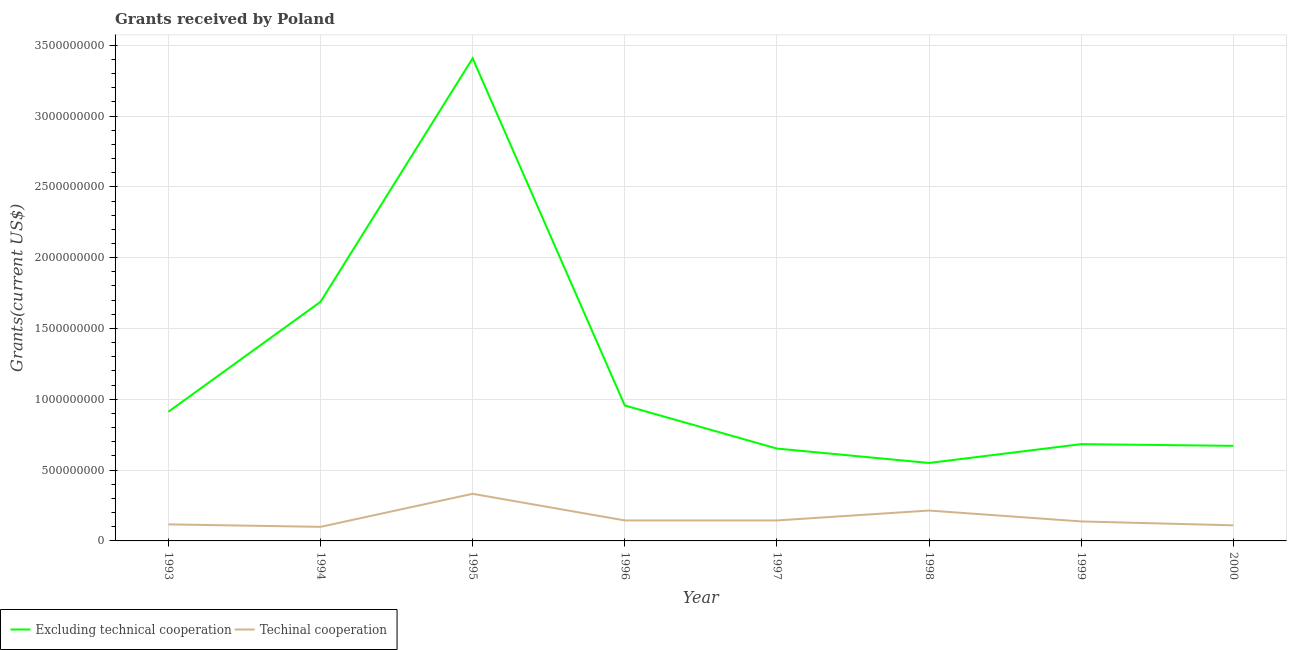What is the amount of grants received(excluding technical cooperation) in 1996?
Make the answer very short. 9.56e+08. Across all years, what is the maximum amount of grants received(including technical cooperation)?
Offer a terse response. 3.33e+08. Across all years, what is the minimum amount of grants received(including technical cooperation)?
Your answer should be compact. 9.94e+07. In which year was the amount of grants received(including technical cooperation) maximum?
Keep it short and to the point. 1995. What is the total amount of grants received(including technical cooperation) in the graph?
Your answer should be very brief. 1.30e+09. What is the difference between the amount of grants received(excluding technical cooperation) in 1997 and that in 1998?
Provide a short and direct response. 1.02e+08. What is the difference between the amount of grants received(including technical cooperation) in 1994 and the amount of grants received(excluding technical cooperation) in 1993?
Offer a very short reply. -8.13e+08. What is the average amount of grants received(including technical cooperation) per year?
Your answer should be very brief. 1.63e+08. In the year 1999, what is the difference between the amount of grants received(including technical cooperation) and amount of grants received(excluding technical cooperation)?
Ensure brevity in your answer.  -5.46e+08. In how many years, is the amount of grants received(excluding technical cooperation) greater than 1900000000 US$?
Your response must be concise. 1. What is the ratio of the amount of grants received(including technical cooperation) in 1999 to that in 2000?
Your response must be concise. 1.25. What is the difference between the highest and the second highest amount of grants received(excluding technical cooperation)?
Your response must be concise. 1.72e+09. What is the difference between the highest and the lowest amount of grants received(excluding technical cooperation)?
Offer a very short reply. 2.86e+09. Is the sum of the amount of grants received(excluding technical cooperation) in 1995 and 1997 greater than the maximum amount of grants received(including technical cooperation) across all years?
Provide a short and direct response. Yes. Is the amount of grants received(including technical cooperation) strictly less than the amount of grants received(excluding technical cooperation) over the years?
Give a very brief answer. Yes. How many years are there in the graph?
Keep it short and to the point. 8. What is the difference between two consecutive major ticks on the Y-axis?
Make the answer very short. 5.00e+08. Are the values on the major ticks of Y-axis written in scientific E-notation?
Give a very brief answer. No. Does the graph contain any zero values?
Make the answer very short. No. Does the graph contain grids?
Make the answer very short. Yes. Where does the legend appear in the graph?
Provide a short and direct response. Bottom left. How are the legend labels stacked?
Provide a succinct answer. Horizontal. What is the title of the graph?
Your answer should be very brief. Grants received by Poland. What is the label or title of the X-axis?
Your answer should be compact. Year. What is the label or title of the Y-axis?
Your answer should be very brief. Grants(current US$). What is the Grants(current US$) in Excluding technical cooperation in 1993?
Offer a very short reply. 9.12e+08. What is the Grants(current US$) of Techinal cooperation in 1993?
Your response must be concise. 1.17e+08. What is the Grants(current US$) of Excluding technical cooperation in 1994?
Your response must be concise. 1.69e+09. What is the Grants(current US$) of Techinal cooperation in 1994?
Your answer should be compact. 9.94e+07. What is the Grants(current US$) of Excluding technical cooperation in 1995?
Offer a very short reply. 3.41e+09. What is the Grants(current US$) of Techinal cooperation in 1995?
Make the answer very short. 3.33e+08. What is the Grants(current US$) of Excluding technical cooperation in 1996?
Give a very brief answer. 9.56e+08. What is the Grants(current US$) of Techinal cooperation in 1996?
Your answer should be very brief. 1.45e+08. What is the Grants(current US$) in Excluding technical cooperation in 1997?
Your answer should be compact. 6.52e+08. What is the Grants(current US$) in Techinal cooperation in 1997?
Provide a succinct answer. 1.45e+08. What is the Grants(current US$) in Excluding technical cooperation in 1998?
Provide a succinct answer. 5.50e+08. What is the Grants(current US$) in Techinal cooperation in 1998?
Ensure brevity in your answer.  2.15e+08. What is the Grants(current US$) of Excluding technical cooperation in 1999?
Your answer should be compact. 6.83e+08. What is the Grants(current US$) in Techinal cooperation in 1999?
Keep it short and to the point. 1.38e+08. What is the Grants(current US$) of Excluding technical cooperation in 2000?
Keep it short and to the point. 6.71e+08. What is the Grants(current US$) of Techinal cooperation in 2000?
Provide a short and direct response. 1.10e+08. Across all years, what is the maximum Grants(current US$) in Excluding technical cooperation?
Ensure brevity in your answer.  3.41e+09. Across all years, what is the maximum Grants(current US$) in Techinal cooperation?
Make the answer very short. 3.33e+08. Across all years, what is the minimum Grants(current US$) in Excluding technical cooperation?
Keep it short and to the point. 5.50e+08. Across all years, what is the minimum Grants(current US$) in Techinal cooperation?
Your response must be concise. 9.94e+07. What is the total Grants(current US$) in Excluding technical cooperation in the graph?
Provide a short and direct response. 9.52e+09. What is the total Grants(current US$) of Techinal cooperation in the graph?
Your answer should be compact. 1.30e+09. What is the difference between the Grants(current US$) of Excluding technical cooperation in 1993 and that in 1994?
Give a very brief answer. -7.76e+08. What is the difference between the Grants(current US$) of Techinal cooperation in 1993 and that in 1994?
Make the answer very short. 1.75e+07. What is the difference between the Grants(current US$) of Excluding technical cooperation in 1993 and that in 1995?
Offer a very short reply. -2.50e+09. What is the difference between the Grants(current US$) in Techinal cooperation in 1993 and that in 1995?
Offer a terse response. -2.16e+08. What is the difference between the Grants(current US$) of Excluding technical cooperation in 1993 and that in 1996?
Your answer should be compact. -4.42e+07. What is the difference between the Grants(current US$) in Techinal cooperation in 1993 and that in 1996?
Ensure brevity in your answer.  -2.78e+07. What is the difference between the Grants(current US$) in Excluding technical cooperation in 1993 and that in 1997?
Your response must be concise. 2.60e+08. What is the difference between the Grants(current US$) in Techinal cooperation in 1993 and that in 1997?
Give a very brief answer. -2.78e+07. What is the difference between the Grants(current US$) in Excluding technical cooperation in 1993 and that in 1998?
Your response must be concise. 3.62e+08. What is the difference between the Grants(current US$) in Techinal cooperation in 1993 and that in 1998?
Offer a very short reply. -9.77e+07. What is the difference between the Grants(current US$) in Excluding technical cooperation in 1993 and that in 1999?
Your answer should be compact. 2.29e+08. What is the difference between the Grants(current US$) in Techinal cooperation in 1993 and that in 1999?
Keep it short and to the point. -2.08e+07. What is the difference between the Grants(current US$) of Excluding technical cooperation in 1993 and that in 2000?
Your response must be concise. 2.41e+08. What is the difference between the Grants(current US$) in Techinal cooperation in 1993 and that in 2000?
Make the answer very short. 6.63e+06. What is the difference between the Grants(current US$) of Excluding technical cooperation in 1994 and that in 1995?
Your answer should be very brief. -1.72e+09. What is the difference between the Grants(current US$) of Techinal cooperation in 1994 and that in 1995?
Ensure brevity in your answer.  -2.33e+08. What is the difference between the Grants(current US$) in Excluding technical cooperation in 1994 and that in 1996?
Keep it short and to the point. 7.32e+08. What is the difference between the Grants(current US$) in Techinal cooperation in 1994 and that in 1996?
Keep it short and to the point. -4.53e+07. What is the difference between the Grants(current US$) of Excluding technical cooperation in 1994 and that in 1997?
Provide a short and direct response. 1.04e+09. What is the difference between the Grants(current US$) in Techinal cooperation in 1994 and that in 1997?
Your answer should be compact. -4.53e+07. What is the difference between the Grants(current US$) in Excluding technical cooperation in 1994 and that in 1998?
Offer a very short reply. 1.14e+09. What is the difference between the Grants(current US$) in Techinal cooperation in 1994 and that in 1998?
Your answer should be compact. -1.15e+08. What is the difference between the Grants(current US$) in Excluding technical cooperation in 1994 and that in 1999?
Provide a succinct answer. 1.00e+09. What is the difference between the Grants(current US$) of Techinal cooperation in 1994 and that in 1999?
Ensure brevity in your answer.  -3.82e+07. What is the difference between the Grants(current US$) of Excluding technical cooperation in 1994 and that in 2000?
Provide a short and direct response. 1.02e+09. What is the difference between the Grants(current US$) of Techinal cooperation in 1994 and that in 2000?
Give a very brief answer. -1.08e+07. What is the difference between the Grants(current US$) of Excluding technical cooperation in 1995 and that in 1996?
Give a very brief answer. 2.45e+09. What is the difference between the Grants(current US$) in Techinal cooperation in 1995 and that in 1996?
Offer a very short reply. 1.88e+08. What is the difference between the Grants(current US$) in Excluding technical cooperation in 1995 and that in 1997?
Your answer should be very brief. 2.76e+09. What is the difference between the Grants(current US$) of Techinal cooperation in 1995 and that in 1997?
Provide a short and direct response. 1.88e+08. What is the difference between the Grants(current US$) of Excluding technical cooperation in 1995 and that in 1998?
Provide a short and direct response. 2.86e+09. What is the difference between the Grants(current US$) in Techinal cooperation in 1995 and that in 1998?
Your answer should be compact. 1.18e+08. What is the difference between the Grants(current US$) in Excluding technical cooperation in 1995 and that in 1999?
Give a very brief answer. 2.72e+09. What is the difference between the Grants(current US$) in Techinal cooperation in 1995 and that in 1999?
Make the answer very short. 1.95e+08. What is the difference between the Grants(current US$) in Excluding technical cooperation in 1995 and that in 2000?
Provide a succinct answer. 2.74e+09. What is the difference between the Grants(current US$) in Techinal cooperation in 1995 and that in 2000?
Your answer should be very brief. 2.23e+08. What is the difference between the Grants(current US$) of Excluding technical cooperation in 1996 and that in 1997?
Give a very brief answer. 3.04e+08. What is the difference between the Grants(current US$) in Excluding technical cooperation in 1996 and that in 1998?
Offer a very short reply. 4.06e+08. What is the difference between the Grants(current US$) in Techinal cooperation in 1996 and that in 1998?
Your response must be concise. -6.99e+07. What is the difference between the Grants(current US$) in Excluding technical cooperation in 1996 and that in 1999?
Offer a terse response. 2.73e+08. What is the difference between the Grants(current US$) of Techinal cooperation in 1996 and that in 1999?
Ensure brevity in your answer.  7.03e+06. What is the difference between the Grants(current US$) of Excluding technical cooperation in 1996 and that in 2000?
Give a very brief answer. 2.85e+08. What is the difference between the Grants(current US$) in Techinal cooperation in 1996 and that in 2000?
Your answer should be very brief. 3.44e+07. What is the difference between the Grants(current US$) in Excluding technical cooperation in 1997 and that in 1998?
Your response must be concise. 1.02e+08. What is the difference between the Grants(current US$) in Techinal cooperation in 1997 and that in 1998?
Offer a very short reply. -6.99e+07. What is the difference between the Grants(current US$) in Excluding technical cooperation in 1997 and that in 1999?
Your answer should be compact. -3.12e+07. What is the difference between the Grants(current US$) in Techinal cooperation in 1997 and that in 1999?
Your answer should be very brief. 7.04e+06. What is the difference between the Grants(current US$) in Excluding technical cooperation in 1997 and that in 2000?
Offer a terse response. -1.92e+07. What is the difference between the Grants(current US$) in Techinal cooperation in 1997 and that in 2000?
Offer a very short reply. 3.44e+07. What is the difference between the Grants(current US$) of Excluding technical cooperation in 1998 and that in 1999?
Your answer should be very brief. -1.33e+08. What is the difference between the Grants(current US$) in Techinal cooperation in 1998 and that in 1999?
Make the answer very short. 7.69e+07. What is the difference between the Grants(current US$) of Excluding technical cooperation in 1998 and that in 2000?
Keep it short and to the point. -1.21e+08. What is the difference between the Grants(current US$) in Techinal cooperation in 1998 and that in 2000?
Keep it short and to the point. 1.04e+08. What is the difference between the Grants(current US$) of Excluding technical cooperation in 1999 and that in 2000?
Keep it short and to the point. 1.20e+07. What is the difference between the Grants(current US$) of Techinal cooperation in 1999 and that in 2000?
Your answer should be compact. 2.74e+07. What is the difference between the Grants(current US$) of Excluding technical cooperation in 1993 and the Grants(current US$) of Techinal cooperation in 1994?
Provide a succinct answer. 8.13e+08. What is the difference between the Grants(current US$) in Excluding technical cooperation in 1993 and the Grants(current US$) in Techinal cooperation in 1995?
Your answer should be very brief. 5.79e+08. What is the difference between the Grants(current US$) in Excluding technical cooperation in 1993 and the Grants(current US$) in Techinal cooperation in 1996?
Keep it short and to the point. 7.68e+08. What is the difference between the Grants(current US$) of Excluding technical cooperation in 1993 and the Grants(current US$) of Techinal cooperation in 1997?
Ensure brevity in your answer.  7.68e+08. What is the difference between the Grants(current US$) in Excluding technical cooperation in 1993 and the Grants(current US$) in Techinal cooperation in 1998?
Offer a terse response. 6.98e+08. What is the difference between the Grants(current US$) of Excluding technical cooperation in 1993 and the Grants(current US$) of Techinal cooperation in 1999?
Your answer should be very brief. 7.75e+08. What is the difference between the Grants(current US$) in Excluding technical cooperation in 1993 and the Grants(current US$) in Techinal cooperation in 2000?
Your response must be concise. 8.02e+08. What is the difference between the Grants(current US$) of Excluding technical cooperation in 1994 and the Grants(current US$) of Techinal cooperation in 1995?
Make the answer very short. 1.36e+09. What is the difference between the Grants(current US$) of Excluding technical cooperation in 1994 and the Grants(current US$) of Techinal cooperation in 1996?
Give a very brief answer. 1.54e+09. What is the difference between the Grants(current US$) of Excluding technical cooperation in 1994 and the Grants(current US$) of Techinal cooperation in 1997?
Your answer should be compact. 1.54e+09. What is the difference between the Grants(current US$) in Excluding technical cooperation in 1994 and the Grants(current US$) in Techinal cooperation in 1998?
Ensure brevity in your answer.  1.47e+09. What is the difference between the Grants(current US$) in Excluding technical cooperation in 1994 and the Grants(current US$) in Techinal cooperation in 1999?
Provide a short and direct response. 1.55e+09. What is the difference between the Grants(current US$) in Excluding technical cooperation in 1994 and the Grants(current US$) in Techinal cooperation in 2000?
Offer a very short reply. 1.58e+09. What is the difference between the Grants(current US$) of Excluding technical cooperation in 1995 and the Grants(current US$) of Techinal cooperation in 1996?
Ensure brevity in your answer.  3.26e+09. What is the difference between the Grants(current US$) of Excluding technical cooperation in 1995 and the Grants(current US$) of Techinal cooperation in 1997?
Offer a very short reply. 3.26e+09. What is the difference between the Grants(current US$) in Excluding technical cooperation in 1995 and the Grants(current US$) in Techinal cooperation in 1998?
Ensure brevity in your answer.  3.19e+09. What is the difference between the Grants(current US$) in Excluding technical cooperation in 1995 and the Grants(current US$) in Techinal cooperation in 1999?
Offer a terse response. 3.27e+09. What is the difference between the Grants(current US$) in Excluding technical cooperation in 1995 and the Grants(current US$) in Techinal cooperation in 2000?
Your answer should be very brief. 3.30e+09. What is the difference between the Grants(current US$) of Excluding technical cooperation in 1996 and the Grants(current US$) of Techinal cooperation in 1997?
Your answer should be very brief. 8.12e+08. What is the difference between the Grants(current US$) in Excluding technical cooperation in 1996 and the Grants(current US$) in Techinal cooperation in 1998?
Keep it short and to the point. 7.42e+08. What is the difference between the Grants(current US$) of Excluding technical cooperation in 1996 and the Grants(current US$) of Techinal cooperation in 1999?
Make the answer very short. 8.19e+08. What is the difference between the Grants(current US$) of Excluding technical cooperation in 1996 and the Grants(current US$) of Techinal cooperation in 2000?
Make the answer very short. 8.46e+08. What is the difference between the Grants(current US$) of Excluding technical cooperation in 1997 and the Grants(current US$) of Techinal cooperation in 1998?
Provide a succinct answer. 4.38e+08. What is the difference between the Grants(current US$) in Excluding technical cooperation in 1997 and the Grants(current US$) in Techinal cooperation in 1999?
Provide a succinct answer. 5.15e+08. What is the difference between the Grants(current US$) in Excluding technical cooperation in 1997 and the Grants(current US$) in Techinal cooperation in 2000?
Provide a short and direct response. 5.42e+08. What is the difference between the Grants(current US$) of Excluding technical cooperation in 1998 and the Grants(current US$) of Techinal cooperation in 1999?
Ensure brevity in your answer.  4.13e+08. What is the difference between the Grants(current US$) in Excluding technical cooperation in 1998 and the Grants(current US$) in Techinal cooperation in 2000?
Give a very brief answer. 4.40e+08. What is the difference between the Grants(current US$) of Excluding technical cooperation in 1999 and the Grants(current US$) of Techinal cooperation in 2000?
Provide a short and direct response. 5.73e+08. What is the average Grants(current US$) of Excluding technical cooperation per year?
Offer a terse response. 1.19e+09. What is the average Grants(current US$) of Techinal cooperation per year?
Give a very brief answer. 1.63e+08. In the year 1993, what is the difference between the Grants(current US$) of Excluding technical cooperation and Grants(current US$) of Techinal cooperation?
Your answer should be very brief. 7.95e+08. In the year 1994, what is the difference between the Grants(current US$) of Excluding technical cooperation and Grants(current US$) of Techinal cooperation?
Your answer should be compact. 1.59e+09. In the year 1995, what is the difference between the Grants(current US$) in Excluding technical cooperation and Grants(current US$) in Techinal cooperation?
Your answer should be compact. 3.07e+09. In the year 1996, what is the difference between the Grants(current US$) of Excluding technical cooperation and Grants(current US$) of Techinal cooperation?
Ensure brevity in your answer.  8.12e+08. In the year 1997, what is the difference between the Grants(current US$) of Excluding technical cooperation and Grants(current US$) of Techinal cooperation?
Provide a succinct answer. 5.08e+08. In the year 1998, what is the difference between the Grants(current US$) of Excluding technical cooperation and Grants(current US$) of Techinal cooperation?
Provide a succinct answer. 3.36e+08. In the year 1999, what is the difference between the Grants(current US$) of Excluding technical cooperation and Grants(current US$) of Techinal cooperation?
Your answer should be compact. 5.46e+08. In the year 2000, what is the difference between the Grants(current US$) in Excluding technical cooperation and Grants(current US$) in Techinal cooperation?
Make the answer very short. 5.61e+08. What is the ratio of the Grants(current US$) in Excluding technical cooperation in 1993 to that in 1994?
Provide a succinct answer. 0.54. What is the ratio of the Grants(current US$) in Techinal cooperation in 1993 to that in 1994?
Provide a short and direct response. 1.18. What is the ratio of the Grants(current US$) of Excluding technical cooperation in 1993 to that in 1995?
Provide a succinct answer. 0.27. What is the ratio of the Grants(current US$) in Techinal cooperation in 1993 to that in 1995?
Provide a succinct answer. 0.35. What is the ratio of the Grants(current US$) in Excluding technical cooperation in 1993 to that in 1996?
Ensure brevity in your answer.  0.95. What is the ratio of the Grants(current US$) of Techinal cooperation in 1993 to that in 1996?
Keep it short and to the point. 0.81. What is the ratio of the Grants(current US$) in Excluding technical cooperation in 1993 to that in 1997?
Provide a succinct answer. 1.4. What is the ratio of the Grants(current US$) of Techinal cooperation in 1993 to that in 1997?
Provide a short and direct response. 0.81. What is the ratio of the Grants(current US$) of Excluding technical cooperation in 1993 to that in 1998?
Keep it short and to the point. 1.66. What is the ratio of the Grants(current US$) of Techinal cooperation in 1993 to that in 1998?
Give a very brief answer. 0.54. What is the ratio of the Grants(current US$) of Excluding technical cooperation in 1993 to that in 1999?
Your answer should be very brief. 1.33. What is the ratio of the Grants(current US$) of Techinal cooperation in 1993 to that in 1999?
Give a very brief answer. 0.85. What is the ratio of the Grants(current US$) of Excluding technical cooperation in 1993 to that in 2000?
Make the answer very short. 1.36. What is the ratio of the Grants(current US$) of Techinal cooperation in 1993 to that in 2000?
Your answer should be compact. 1.06. What is the ratio of the Grants(current US$) of Excluding technical cooperation in 1994 to that in 1995?
Your response must be concise. 0.5. What is the ratio of the Grants(current US$) of Techinal cooperation in 1994 to that in 1995?
Give a very brief answer. 0.3. What is the ratio of the Grants(current US$) of Excluding technical cooperation in 1994 to that in 1996?
Offer a terse response. 1.77. What is the ratio of the Grants(current US$) in Techinal cooperation in 1994 to that in 1996?
Keep it short and to the point. 0.69. What is the ratio of the Grants(current US$) of Excluding technical cooperation in 1994 to that in 1997?
Ensure brevity in your answer.  2.59. What is the ratio of the Grants(current US$) of Techinal cooperation in 1994 to that in 1997?
Your answer should be compact. 0.69. What is the ratio of the Grants(current US$) in Excluding technical cooperation in 1994 to that in 1998?
Your answer should be compact. 3.07. What is the ratio of the Grants(current US$) in Techinal cooperation in 1994 to that in 1998?
Your answer should be very brief. 0.46. What is the ratio of the Grants(current US$) in Excluding technical cooperation in 1994 to that in 1999?
Ensure brevity in your answer.  2.47. What is the ratio of the Grants(current US$) of Techinal cooperation in 1994 to that in 1999?
Make the answer very short. 0.72. What is the ratio of the Grants(current US$) in Excluding technical cooperation in 1994 to that in 2000?
Your response must be concise. 2.51. What is the ratio of the Grants(current US$) in Techinal cooperation in 1994 to that in 2000?
Ensure brevity in your answer.  0.9. What is the ratio of the Grants(current US$) of Excluding technical cooperation in 1995 to that in 1996?
Your response must be concise. 3.56. What is the ratio of the Grants(current US$) of Techinal cooperation in 1995 to that in 1996?
Offer a very short reply. 2.3. What is the ratio of the Grants(current US$) in Excluding technical cooperation in 1995 to that in 1997?
Your answer should be compact. 5.23. What is the ratio of the Grants(current US$) in Techinal cooperation in 1995 to that in 1997?
Your answer should be compact. 2.3. What is the ratio of the Grants(current US$) of Excluding technical cooperation in 1995 to that in 1998?
Offer a very short reply. 6.19. What is the ratio of the Grants(current US$) in Techinal cooperation in 1995 to that in 1998?
Your answer should be very brief. 1.55. What is the ratio of the Grants(current US$) of Excluding technical cooperation in 1995 to that in 1999?
Offer a terse response. 4.99. What is the ratio of the Grants(current US$) of Techinal cooperation in 1995 to that in 1999?
Your answer should be very brief. 2.42. What is the ratio of the Grants(current US$) in Excluding technical cooperation in 1995 to that in 2000?
Provide a succinct answer. 5.08. What is the ratio of the Grants(current US$) of Techinal cooperation in 1995 to that in 2000?
Your answer should be compact. 3.02. What is the ratio of the Grants(current US$) in Excluding technical cooperation in 1996 to that in 1997?
Your answer should be very brief. 1.47. What is the ratio of the Grants(current US$) of Excluding technical cooperation in 1996 to that in 1998?
Ensure brevity in your answer.  1.74. What is the ratio of the Grants(current US$) in Techinal cooperation in 1996 to that in 1998?
Your answer should be very brief. 0.67. What is the ratio of the Grants(current US$) of Excluding technical cooperation in 1996 to that in 1999?
Make the answer very short. 1.4. What is the ratio of the Grants(current US$) in Techinal cooperation in 1996 to that in 1999?
Ensure brevity in your answer.  1.05. What is the ratio of the Grants(current US$) in Excluding technical cooperation in 1996 to that in 2000?
Ensure brevity in your answer.  1.42. What is the ratio of the Grants(current US$) of Techinal cooperation in 1996 to that in 2000?
Make the answer very short. 1.31. What is the ratio of the Grants(current US$) in Excluding technical cooperation in 1997 to that in 1998?
Offer a very short reply. 1.18. What is the ratio of the Grants(current US$) in Techinal cooperation in 1997 to that in 1998?
Your response must be concise. 0.67. What is the ratio of the Grants(current US$) in Excluding technical cooperation in 1997 to that in 1999?
Your answer should be compact. 0.95. What is the ratio of the Grants(current US$) in Techinal cooperation in 1997 to that in 1999?
Offer a very short reply. 1.05. What is the ratio of the Grants(current US$) of Excluding technical cooperation in 1997 to that in 2000?
Provide a short and direct response. 0.97. What is the ratio of the Grants(current US$) of Techinal cooperation in 1997 to that in 2000?
Ensure brevity in your answer.  1.31. What is the ratio of the Grants(current US$) in Excluding technical cooperation in 1998 to that in 1999?
Your response must be concise. 0.81. What is the ratio of the Grants(current US$) in Techinal cooperation in 1998 to that in 1999?
Provide a succinct answer. 1.56. What is the ratio of the Grants(current US$) of Excluding technical cooperation in 1998 to that in 2000?
Give a very brief answer. 0.82. What is the ratio of the Grants(current US$) of Techinal cooperation in 1998 to that in 2000?
Ensure brevity in your answer.  1.95. What is the ratio of the Grants(current US$) in Excluding technical cooperation in 1999 to that in 2000?
Your response must be concise. 1.02. What is the ratio of the Grants(current US$) in Techinal cooperation in 1999 to that in 2000?
Your response must be concise. 1.25. What is the difference between the highest and the second highest Grants(current US$) of Excluding technical cooperation?
Make the answer very short. 1.72e+09. What is the difference between the highest and the second highest Grants(current US$) in Techinal cooperation?
Make the answer very short. 1.18e+08. What is the difference between the highest and the lowest Grants(current US$) of Excluding technical cooperation?
Give a very brief answer. 2.86e+09. What is the difference between the highest and the lowest Grants(current US$) of Techinal cooperation?
Provide a succinct answer. 2.33e+08. 